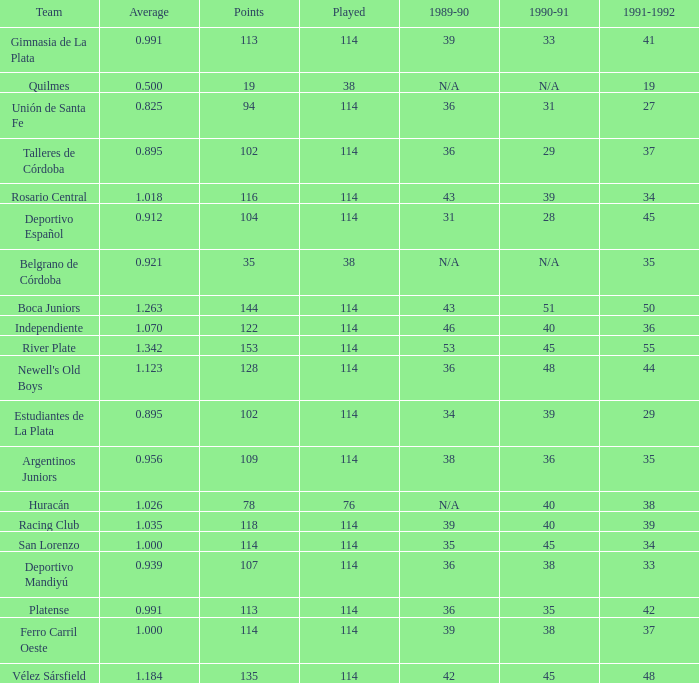How much Played has an Average smaller than 0.9390000000000001, and a 1990-91 of 28? 1.0. 